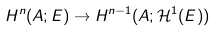<formula> <loc_0><loc_0><loc_500><loc_500>H ^ { n } ( A ; E ) \rightarrow H ^ { n - 1 } ( A ; \mathcal { H } ^ { 1 } ( E ) )</formula> 